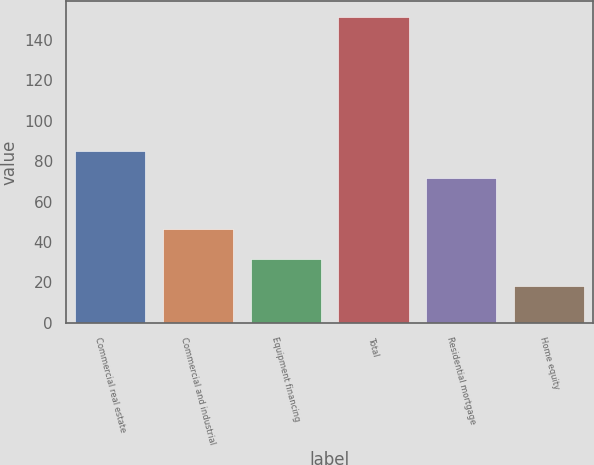<chart> <loc_0><loc_0><loc_500><loc_500><bar_chart><fcel>Commercial real estate<fcel>Commercial and industrial<fcel>Equipment financing<fcel>Total<fcel>Residential mortgage<fcel>Home equity<nl><fcel>85.16<fcel>46.4<fcel>31.36<fcel>151.6<fcel>71.8<fcel>18<nl></chart> 